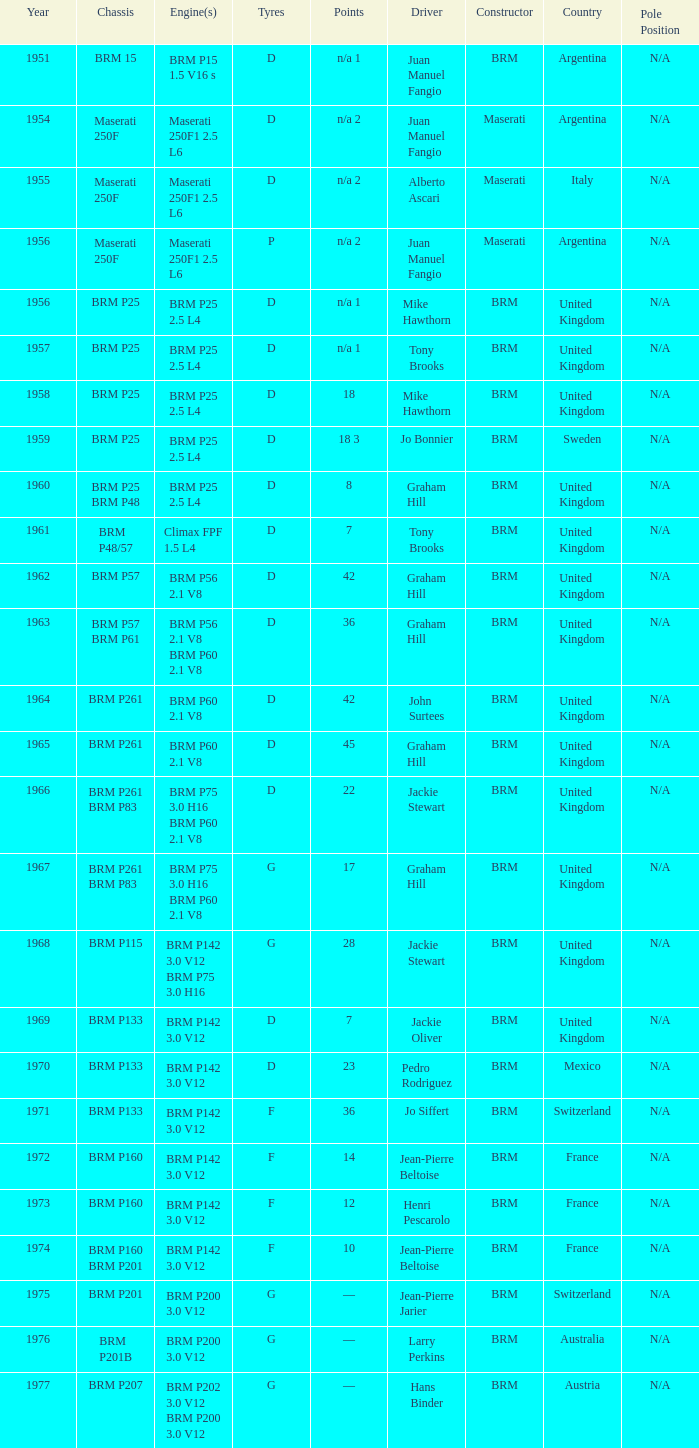Name the point for 1974 10.0. 